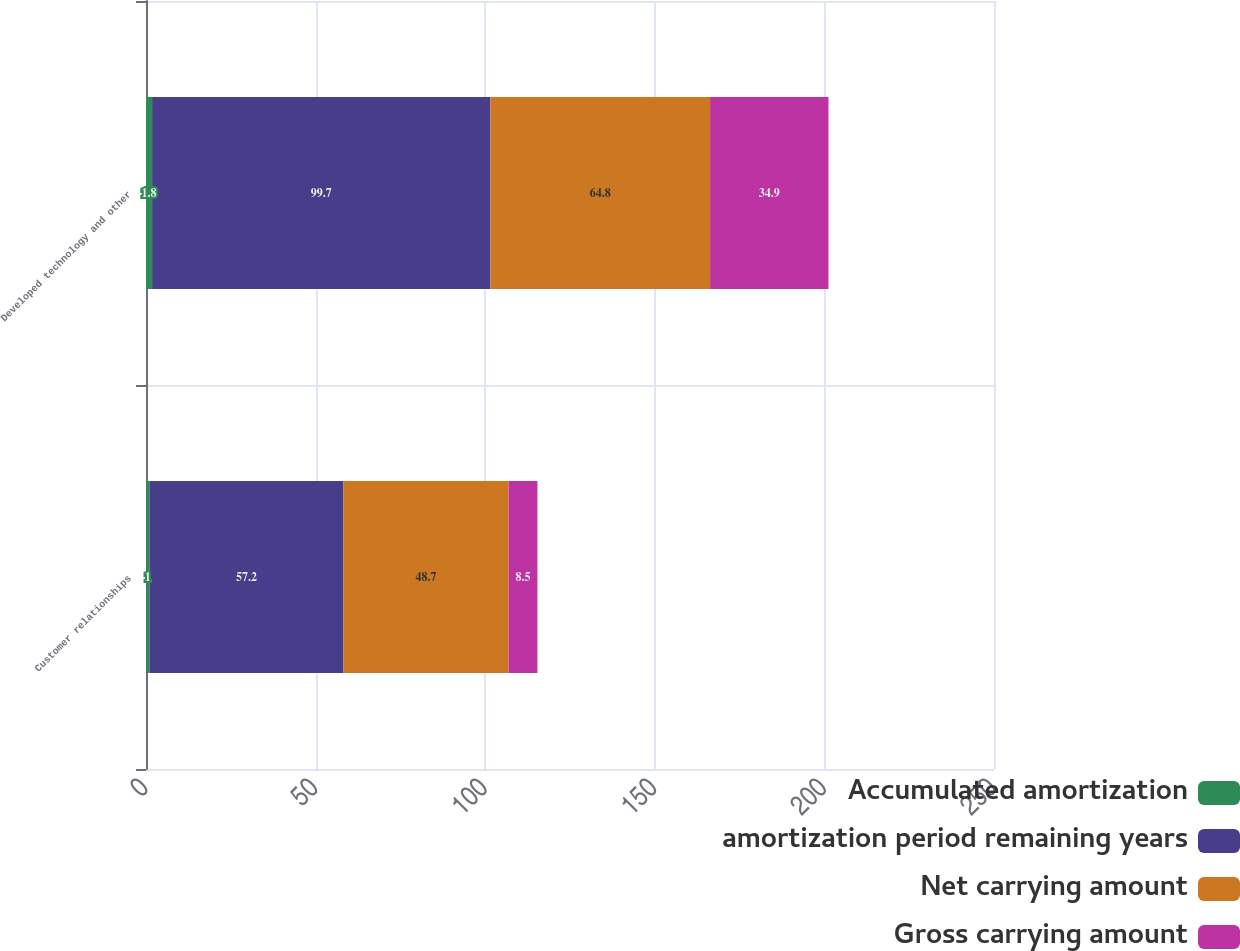<chart> <loc_0><loc_0><loc_500><loc_500><stacked_bar_chart><ecel><fcel>Customer relationships<fcel>Developed technology and other<nl><fcel>Accumulated amortization<fcel>1<fcel>1.8<nl><fcel>amortization period remaining years<fcel>57.2<fcel>99.7<nl><fcel>Net carrying amount<fcel>48.7<fcel>64.8<nl><fcel>Gross carrying amount<fcel>8.5<fcel>34.9<nl></chart> 